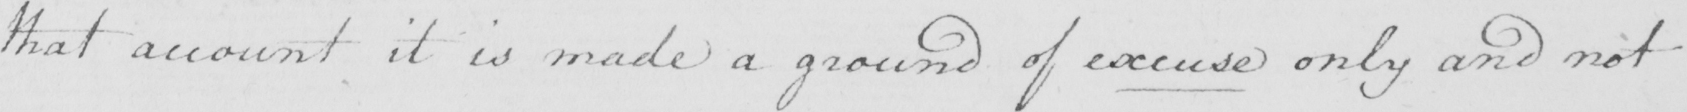What does this handwritten line say? that account it is made a ground of excuse only and not 